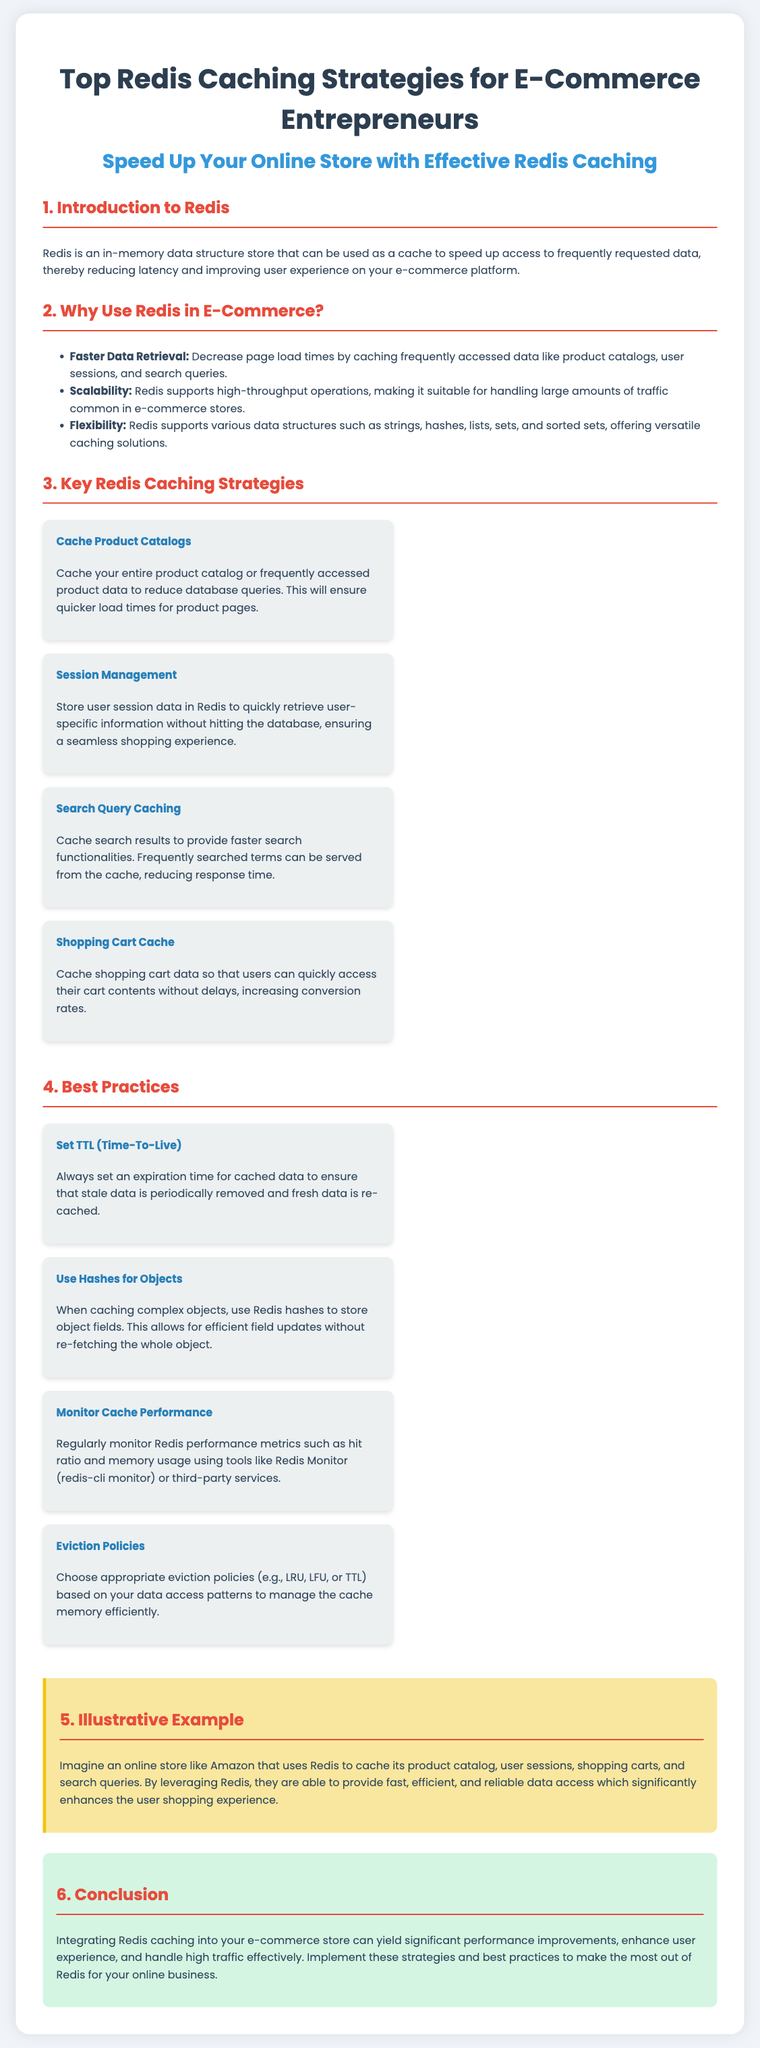what is Redis? Redis is described in the document as an in-memory data structure store that can be used as a cache to speed up access to frequently requested data.
Answer: an in-memory data structure store what are two benefits of using Redis in e-commerce? The document lists several benefits, including faster data retrieval and scalability.
Answer: faster data retrieval, scalability how many key Redis caching strategies are listed? The document outlines four key caching strategies for e-commerce entrepreneurs.
Answer: four what caching strategy involves user-specific information? The strategy focusing on user-specific information is stored user session data in Redis.
Answer: session management what is the purpose of setting TTL? The document explains that setting TTL ensures that stale data is periodically removed and fresh data is re-cached.
Answer: to ensure stale data is removed which Redis data structure allows efficient field updates? The document mentions Redis hashes as a suitable structure for efficiently updating object fields.
Answer: hashes what is the illustrative example given in the document? The illustrative example discusses an online store like Amazon using Redis to cache various data types.
Answer: Amazon caching product catalog, user sessions, shopping carts, search queries what is one recommended eviction policy mentioned? The document refers to appropriate eviction policies such as LRU.
Answer: LRU how does integrating Redis benefit e-commerce stores? The conclusion specifies that integrating Redis yields significant performance improvements and enhances user experience.
Answer: significant performance improvements, enhances user experience 